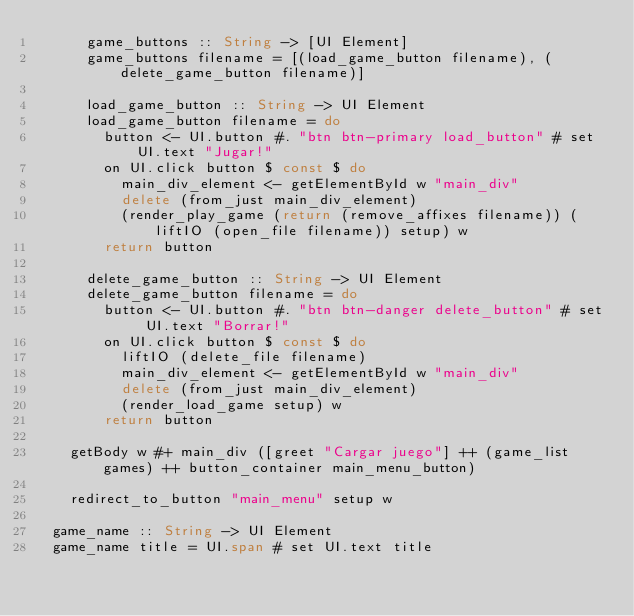Convert code to text. <code><loc_0><loc_0><loc_500><loc_500><_Haskell_>      game_buttons :: String -> [UI Element]
      game_buttons filename = [(load_game_button filename), (delete_game_button filename)]

      load_game_button :: String -> UI Element
      load_game_button filename = do
        button <- UI.button #. "btn btn-primary load_button" # set UI.text "Jugar!"
        on UI.click button $ const $ do
          main_div_element <- getElementById w "main_div"
          delete (from_just main_div_element)
          (render_play_game (return (remove_affixes filename)) (liftIO (open_file filename)) setup) w
        return button

      delete_game_button :: String -> UI Element
      delete_game_button filename = do
        button <- UI.button #. "btn btn-danger delete_button" # set UI.text "Borrar!"
        on UI.click button $ const $ do
          liftIO (delete_file filename)
          main_div_element <- getElementById w "main_div"
          delete (from_just main_div_element)
          (render_load_game setup) w
        return button

    getBody w #+ main_div ([greet "Cargar juego"] ++ (game_list games) ++ button_container main_menu_button)

    redirect_to_button "main_menu" setup w

  game_name :: String -> UI Element
  game_name title = UI.span # set UI.text title</code> 